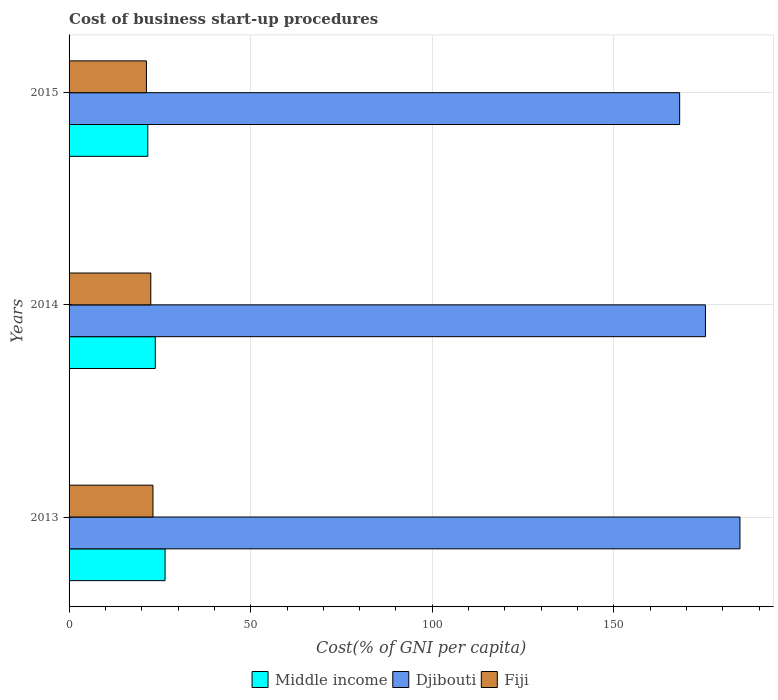How many different coloured bars are there?
Your response must be concise. 3. What is the label of the 2nd group of bars from the top?
Provide a short and direct response. 2014. Across all years, what is the maximum cost of business start-up procedures in Middle income?
Give a very brief answer. 26.43. Across all years, what is the minimum cost of business start-up procedures in Middle income?
Offer a terse response. 21.68. In which year was the cost of business start-up procedures in Djibouti minimum?
Your answer should be compact. 2015. What is the total cost of business start-up procedures in Djibouti in the graph?
Offer a very short reply. 528. What is the difference between the cost of business start-up procedures in Fiji in 2013 and that in 2014?
Your response must be concise. 0.6. What is the difference between the cost of business start-up procedures in Djibouti in 2013 and the cost of business start-up procedures in Fiji in 2015?
Provide a succinct answer. 163.4. What is the average cost of business start-up procedures in Middle income per year?
Offer a very short reply. 23.95. In the year 2013, what is the difference between the cost of business start-up procedures in Fiji and cost of business start-up procedures in Djibouti?
Provide a short and direct response. -161.6. In how many years, is the cost of business start-up procedures in Middle income greater than 60 %?
Provide a short and direct response. 0. What is the ratio of the cost of business start-up procedures in Middle income in 2014 to that in 2015?
Keep it short and to the point. 1.1. Is the difference between the cost of business start-up procedures in Fiji in 2013 and 2015 greater than the difference between the cost of business start-up procedures in Djibouti in 2013 and 2015?
Make the answer very short. No. What is the difference between the highest and the second highest cost of business start-up procedures in Fiji?
Offer a very short reply. 0.6. What is the difference between the highest and the lowest cost of business start-up procedures in Middle income?
Provide a succinct answer. 4.75. Is the sum of the cost of business start-up procedures in Djibouti in 2013 and 2015 greater than the maximum cost of business start-up procedures in Middle income across all years?
Give a very brief answer. Yes. What does the 1st bar from the top in 2013 represents?
Give a very brief answer. Fiji. What does the 2nd bar from the bottom in 2014 represents?
Make the answer very short. Djibouti. How many years are there in the graph?
Provide a short and direct response. 3. What is the difference between two consecutive major ticks on the X-axis?
Keep it short and to the point. 50. Are the values on the major ticks of X-axis written in scientific E-notation?
Keep it short and to the point. No. Does the graph contain any zero values?
Ensure brevity in your answer.  No. Does the graph contain grids?
Make the answer very short. Yes. What is the title of the graph?
Ensure brevity in your answer.  Cost of business start-up procedures. Does "Lao PDR" appear as one of the legend labels in the graph?
Provide a succinct answer. No. What is the label or title of the X-axis?
Provide a succinct answer. Cost(% of GNI per capita). What is the Cost(% of GNI per capita) of Middle income in 2013?
Offer a terse response. 26.43. What is the Cost(% of GNI per capita) of Djibouti in 2013?
Your answer should be very brief. 184.7. What is the Cost(% of GNI per capita) in Fiji in 2013?
Offer a terse response. 23.1. What is the Cost(% of GNI per capita) of Middle income in 2014?
Give a very brief answer. 23.74. What is the Cost(% of GNI per capita) in Djibouti in 2014?
Make the answer very short. 175.2. What is the Cost(% of GNI per capita) of Middle income in 2015?
Give a very brief answer. 21.68. What is the Cost(% of GNI per capita) of Djibouti in 2015?
Make the answer very short. 168.1. What is the Cost(% of GNI per capita) of Fiji in 2015?
Your answer should be very brief. 21.3. Across all years, what is the maximum Cost(% of GNI per capita) in Middle income?
Your answer should be compact. 26.43. Across all years, what is the maximum Cost(% of GNI per capita) of Djibouti?
Provide a short and direct response. 184.7. Across all years, what is the maximum Cost(% of GNI per capita) of Fiji?
Keep it short and to the point. 23.1. Across all years, what is the minimum Cost(% of GNI per capita) in Middle income?
Give a very brief answer. 21.68. Across all years, what is the minimum Cost(% of GNI per capita) in Djibouti?
Keep it short and to the point. 168.1. Across all years, what is the minimum Cost(% of GNI per capita) in Fiji?
Offer a very short reply. 21.3. What is the total Cost(% of GNI per capita) of Middle income in the graph?
Offer a very short reply. 71.84. What is the total Cost(% of GNI per capita) in Djibouti in the graph?
Provide a short and direct response. 528. What is the total Cost(% of GNI per capita) in Fiji in the graph?
Keep it short and to the point. 66.9. What is the difference between the Cost(% of GNI per capita) of Middle income in 2013 and that in 2014?
Provide a short and direct response. 2.69. What is the difference between the Cost(% of GNI per capita) of Djibouti in 2013 and that in 2014?
Give a very brief answer. 9.5. What is the difference between the Cost(% of GNI per capita) in Middle income in 2013 and that in 2015?
Keep it short and to the point. 4.75. What is the difference between the Cost(% of GNI per capita) in Middle income in 2014 and that in 2015?
Your answer should be compact. 2.06. What is the difference between the Cost(% of GNI per capita) in Djibouti in 2014 and that in 2015?
Your answer should be compact. 7.1. What is the difference between the Cost(% of GNI per capita) in Fiji in 2014 and that in 2015?
Ensure brevity in your answer.  1.2. What is the difference between the Cost(% of GNI per capita) in Middle income in 2013 and the Cost(% of GNI per capita) in Djibouti in 2014?
Offer a very short reply. -148.77. What is the difference between the Cost(% of GNI per capita) of Middle income in 2013 and the Cost(% of GNI per capita) of Fiji in 2014?
Give a very brief answer. 3.93. What is the difference between the Cost(% of GNI per capita) in Djibouti in 2013 and the Cost(% of GNI per capita) in Fiji in 2014?
Provide a short and direct response. 162.2. What is the difference between the Cost(% of GNI per capita) in Middle income in 2013 and the Cost(% of GNI per capita) in Djibouti in 2015?
Provide a succinct answer. -141.67. What is the difference between the Cost(% of GNI per capita) of Middle income in 2013 and the Cost(% of GNI per capita) of Fiji in 2015?
Provide a succinct answer. 5.13. What is the difference between the Cost(% of GNI per capita) in Djibouti in 2013 and the Cost(% of GNI per capita) in Fiji in 2015?
Your response must be concise. 163.4. What is the difference between the Cost(% of GNI per capita) of Middle income in 2014 and the Cost(% of GNI per capita) of Djibouti in 2015?
Keep it short and to the point. -144.36. What is the difference between the Cost(% of GNI per capita) of Middle income in 2014 and the Cost(% of GNI per capita) of Fiji in 2015?
Ensure brevity in your answer.  2.44. What is the difference between the Cost(% of GNI per capita) in Djibouti in 2014 and the Cost(% of GNI per capita) in Fiji in 2015?
Your response must be concise. 153.9. What is the average Cost(% of GNI per capita) of Middle income per year?
Keep it short and to the point. 23.95. What is the average Cost(% of GNI per capita) of Djibouti per year?
Give a very brief answer. 176. What is the average Cost(% of GNI per capita) of Fiji per year?
Your answer should be compact. 22.3. In the year 2013, what is the difference between the Cost(% of GNI per capita) of Middle income and Cost(% of GNI per capita) of Djibouti?
Provide a short and direct response. -158.27. In the year 2013, what is the difference between the Cost(% of GNI per capita) of Middle income and Cost(% of GNI per capita) of Fiji?
Your answer should be compact. 3.33. In the year 2013, what is the difference between the Cost(% of GNI per capita) in Djibouti and Cost(% of GNI per capita) in Fiji?
Give a very brief answer. 161.6. In the year 2014, what is the difference between the Cost(% of GNI per capita) in Middle income and Cost(% of GNI per capita) in Djibouti?
Offer a terse response. -151.46. In the year 2014, what is the difference between the Cost(% of GNI per capita) of Middle income and Cost(% of GNI per capita) of Fiji?
Provide a short and direct response. 1.24. In the year 2014, what is the difference between the Cost(% of GNI per capita) of Djibouti and Cost(% of GNI per capita) of Fiji?
Make the answer very short. 152.7. In the year 2015, what is the difference between the Cost(% of GNI per capita) of Middle income and Cost(% of GNI per capita) of Djibouti?
Make the answer very short. -146.42. In the year 2015, what is the difference between the Cost(% of GNI per capita) of Middle income and Cost(% of GNI per capita) of Fiji?
Make the answer very short. 0.38. In the year 2015, what is the difference between the Cost(% of GNI per capita) in Djibouti and Cost(% of GNI per capita) in Fiji?
Offer a terse response. 146.8. What is the ratio of the Cost(% of GNI per capita) in Middle income in 2013 to that in 2014?
Give a very brief answer. 1.11. What is the ratio of the Cost(% of GNI per capita) of Djibouti in 2013 to that in 2014?
Ensure brevity in your answer.  1.05. What is the ratio of the Cost(% of GNI per capita) in Fiji in 2013 to that in 2014?
Your answer should be very brief. 1.03. What is the ratio of the Cost(% of GNI per capita) in Middle income in 2013 to that in 2015?
Your response must be concise. 1.22. What is the ratio of the Cost(% of GNI per capita) in Djibouti in 2013 to that in 2015?
Keep it short and to the point. 1.1. What is the ratio of the Cost(% of GNI per capita) in Fiji in 2013 to that in 2015?
Ensure brevity in your answer.  1.08. What is the ratio of the Cost(% of GNI per capita) in Middle income in 2014 to that in 2015?
Your response must be concise. 1.1. What is the ratio of the Cost(% of GNI per capita) of Djibouti in 2014 to that in 2015?
Keep it short and to the point. 1.04. What is the ratio of the Cost(% of GNI per capita) in Fiji in 2014 to that in 2015?
Provide a short and direct response. 1.06. What is the difference between the highest and the second highest Cost(% of GNI per capita) in Middle income?
Provide a succinct answer. 2.69. What is the difference between the highest and the second highest Cost(% of GNI per capita) in Djibouti?
Keep it short and to the point. 9.5. What is the difference between the highest and the lowest Cost(% of GNI per capita) of Middle income?
Your answer should be compact. 4.75. What is the difference between the highest and the lowest Cost(% of GNI per capita) of Djibouti?
Ensure brevity in your answer.  16.6. What is the difference between the highest and the lowest Cost(% of GNI per capita) in Fiji?
Ensure brevity in your answer.  1.8. 